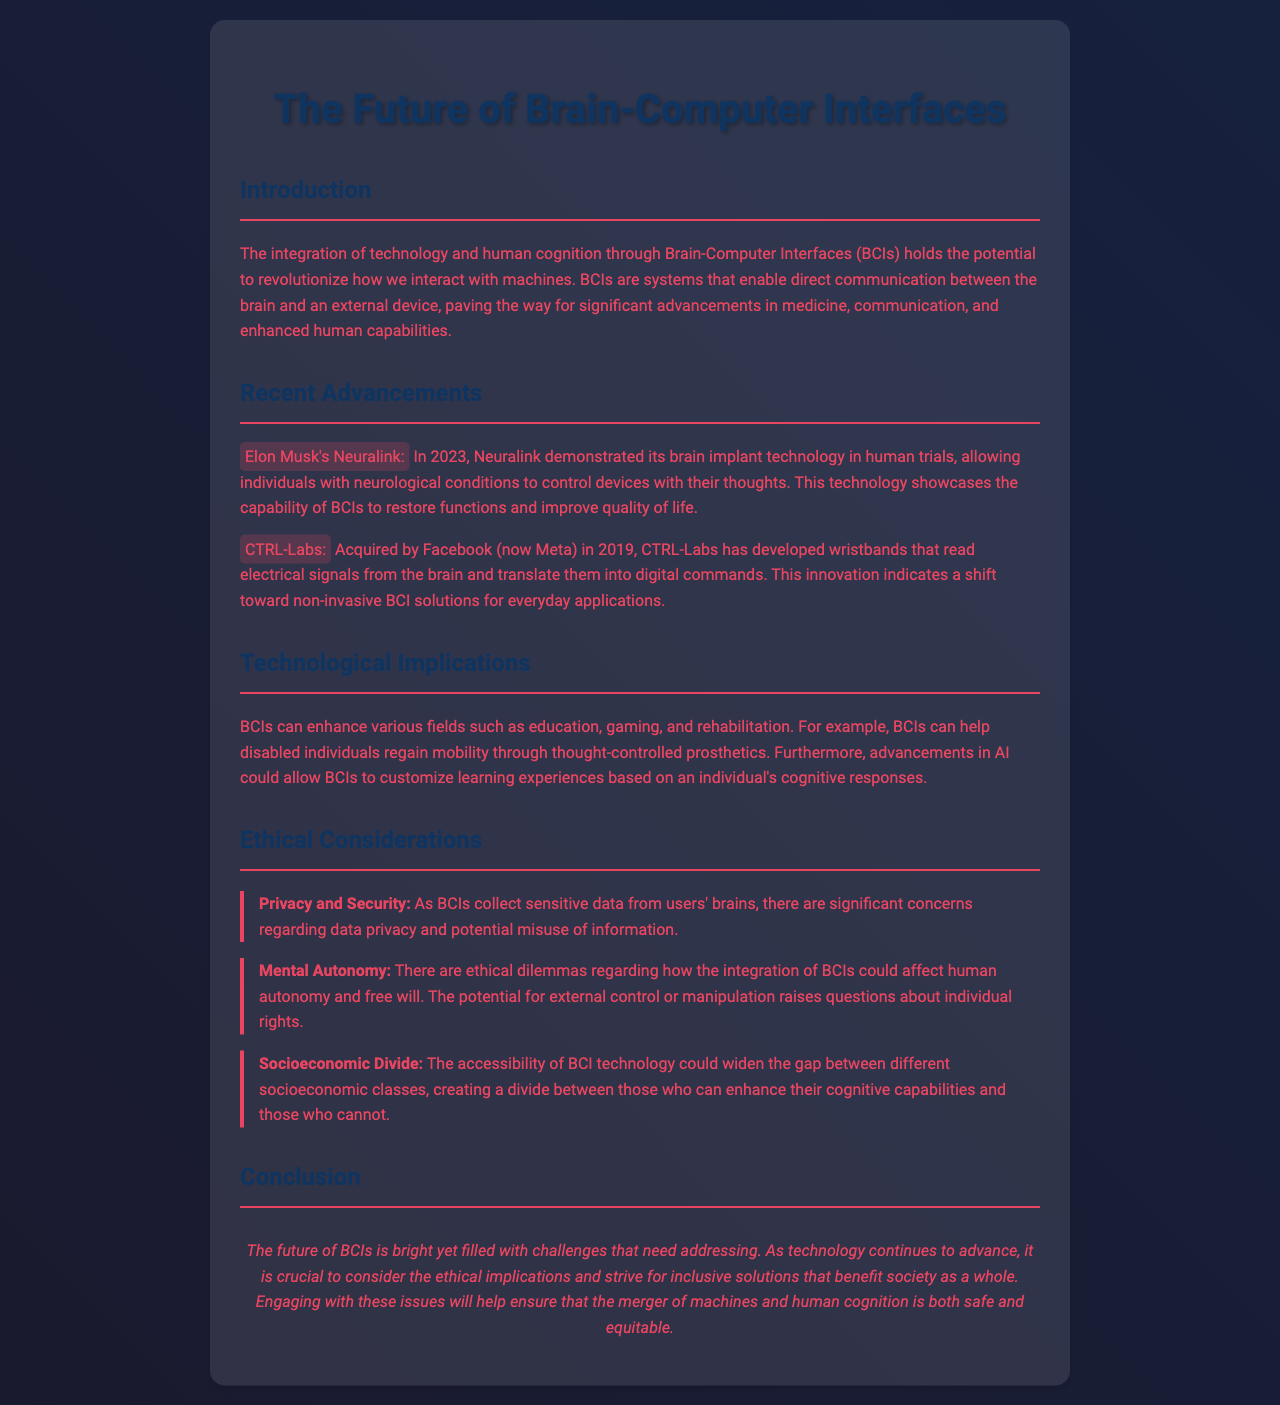what is the name of the company that demonstrated brain implant technology in 2023? The document mentions Neuralink as the company that demonstrated its brain implant technology in human trials in 2023.
Answer: Neuralink what specific technological advancement did CTRL-Labs create? The document states that CTRL-Labs developed wristbands that read electrical signals from the brain and translate them into digital commands.
Answer: Wristbands what year did CTRL-Labs get acquired by Facebook? The document indicates that CTRL-Labs was acquired by Facebook (now Meta) in 2019.
Answer: 2019 what ethical concern is raised regarding the data collected by BCIs? The document discusses significant concerns regarding data privacy as BCIs collect sensitive data from users' brains.
Answer: Privacy which technological field can BCIs enhance according to the document? The document mentions education, gaming, and rehabilitation as fields that BCIs can enhance.
Answer: Education, gaming, rehabilitation what is a potential consequence of BCI technology on socioeconomic classes? The document states that the accessibility of BCI technology could widen the gap between different socioeconomic classes.
Answer: Wider gap what is mentioned as a crucial consideration alongside advancements in BCI technology? The document highlights the importance of addressing ethical implications as technology continues to advance.
Answer: Ethical implications what is the document's conclusion regarding the future of BCIs? The document concludes that the future of BCIs is bright yet filled with challenges that need addressing.
Answer: Bright yet filled with challenges 